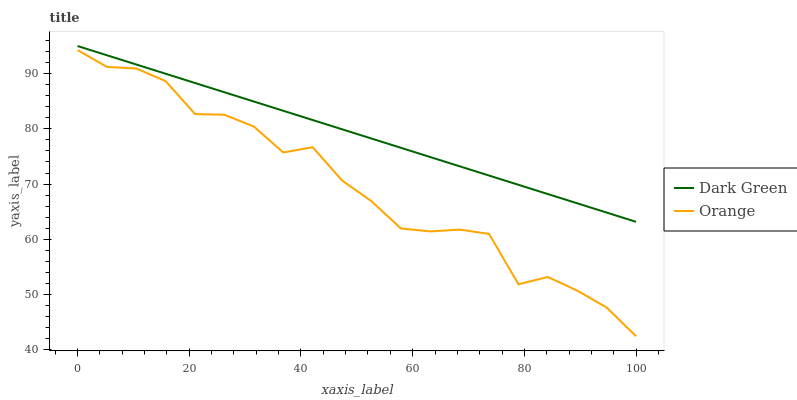Does Orange have the minimum area under the curve?
Answer yes or no. Yes. Does Dark Green have the maximum area under the curve?
Answer yes or no. Yes. Does Dark Green have the minimum area under the curve?
Answer yes or no. No. Is Dark Green the smoothest?
Answer yes or no. Yes. Is Orange the roughest?
Answer yes or no. Yes. Is Dark Green the roughest?
Answer yes or no. No. Does Orange have the lowest value?
Answer yes or no. Yes. Does Dark Green have the lowest value?
Answer yes or no. No. Does Dark Green have the highest value?
Answer yes or no. Yes. Is Orange less than Dark Green?
Answer yes or no. Yes. Is Dark Green greater than Orange?
Answer yes or no. Yes. Does Orange intersect Dark Green?
Answer yes or no. No. 